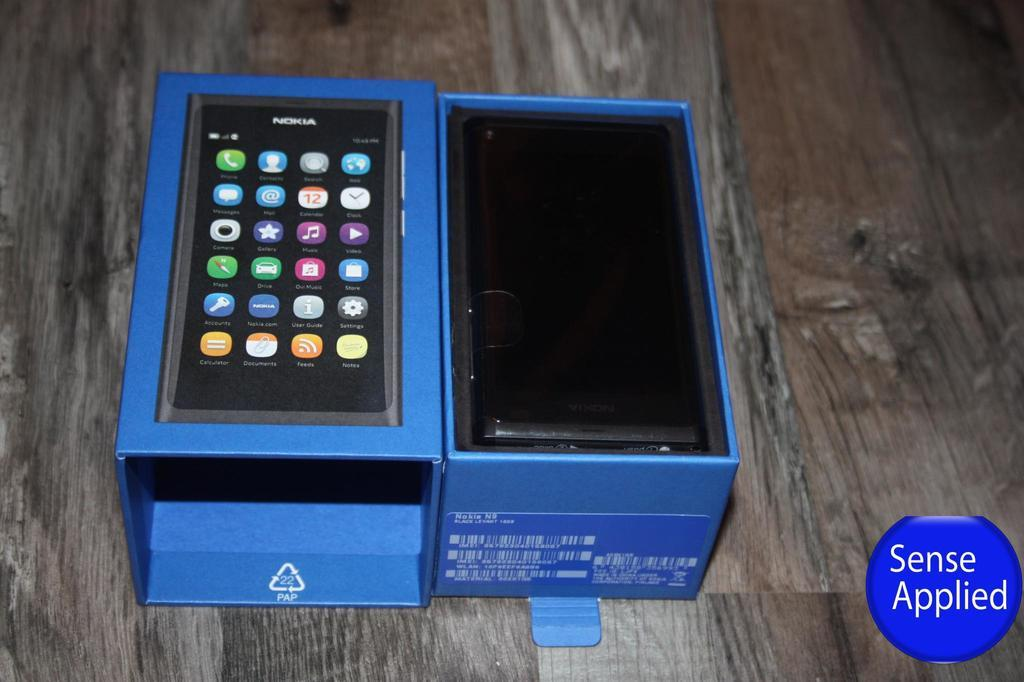<image>
Create a compact narrative representing the image presented. A blue box that contains a smartphone in it 